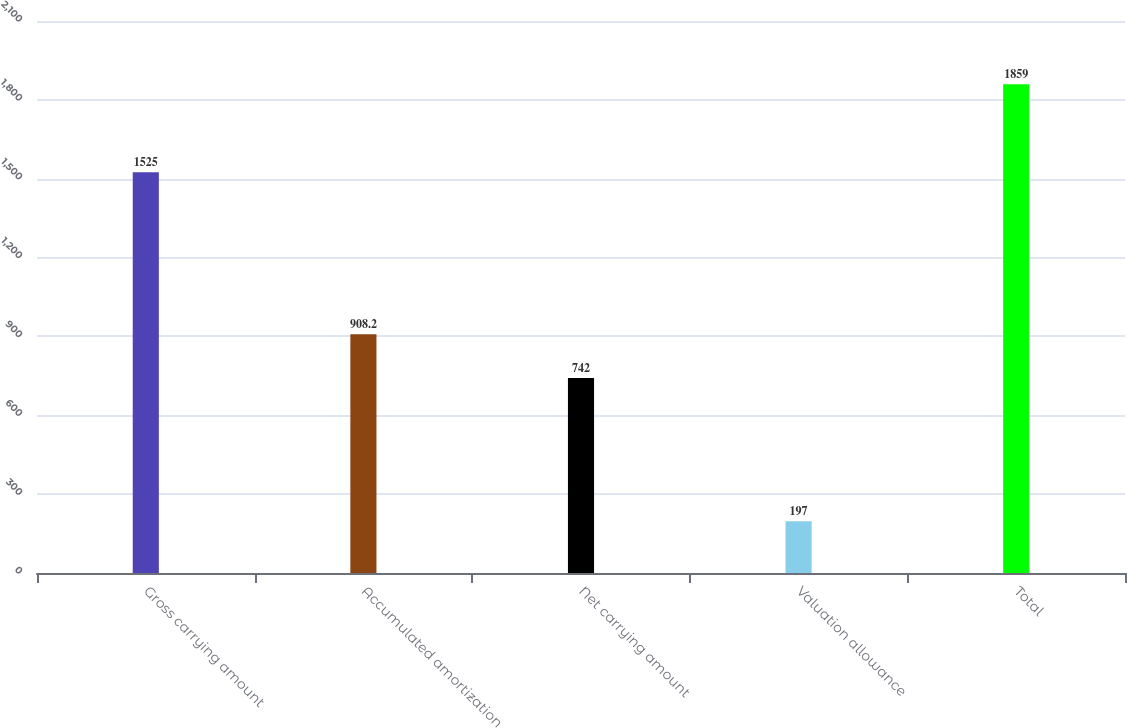Convert chart. <chart><loc_0><loc_0><loc_500><loc_500><bar_chart><fcel>Gross carrying amount<fcel>Accumulated amortization<fcel>Net carrying amount<fcel>Valuation allowance<fcel>Total<nl><fcel>1525<fcel>908.2<fcel>742<fcel>197<fcel>1859<nl></chart> 